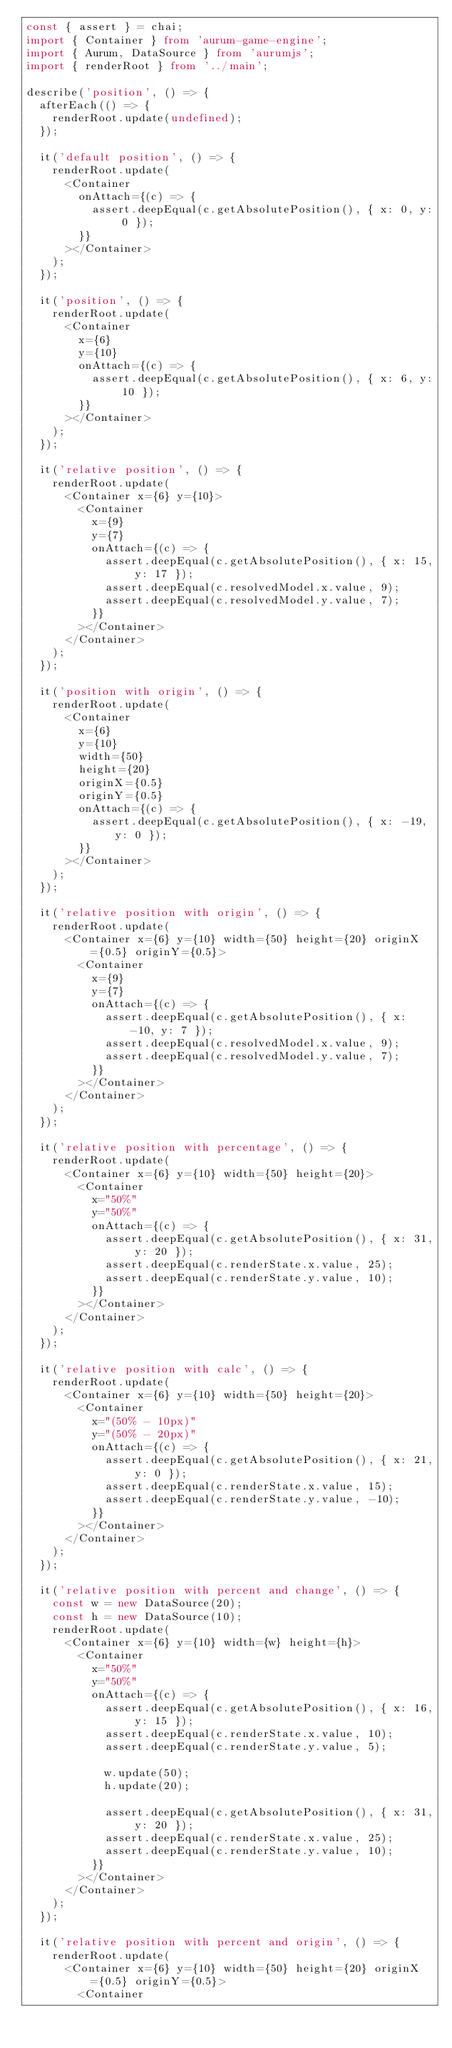Convert code to text. <code><loc_0><loc_0><loc_500><loc_500><_TypeScript_>const { assert } = chai;
import { Container } from 'aurum-game-engine';
import { Aurum, DataSource } from 'aurumjs';
import { renderRoot } from '../main';

describe('position', () => {
	afterEach(() => {
		renderRoot.update(undefined);
	});

	it('default position', () => {
		renderRoot.update(
			<Container
				onAttach={(c) => {
					assert.deepEqual(c.getAbsolutePosition(), { x: 0, y: 0 });
				}}
			></Container>
		);
	});

	it('position', () => {
		renderRoot.update(
			<Container
				x={6}
				y={10}
				onAttach={(c) => {
					assert.deepEqual(c.getAbsolutePosition(), { x: 6, y: 10 });
				}}
			></Container>
		);
	});

	it('relative position', () => {
		renderRoot.update(
			<Container x={6} y={10}>
				<Container
					x={9}
					y={7}
					onAttach={(c) => {
						assert.deepEqual(c.getAbsolutePosition(), { x: 15, y: 17 });
						assert.deepEqual(c.resolvedModel.x.value, 9);
						assert.deepEqual(c.resolvedModel.y.value, 7);
					}}
				></Container>
			</Container>
		);
	});

	it('position with origin', () => {
		renderRoot.update(
			<Container
				x={6}
				y={10}
				width={50}
				height={20}
				originX={0.5}
				originY={0.5}
				onAttach={(c) => {
					assert.deepEqual(c.getAbsolutePosition(), { x: -19, y: 0 });
				}}
			></Container>
		);
	});

	it('relative position with origin', () => {
		renderRoot.update(
			<Container x={6} y={10} width={50} height={20} originX={0.5} originY={0.5}>
				<Container
					x={9}
					y={7}
					onAttach={(c) => {
						assert.deepEqual(c.getAbsolutePosition(), { x: -10, y: 7 });
						assert.deepEqual(c.resolvedModel.x.value, 9);
						assert.deepEqual(c.resolvedModel.y.value, 7);
					}}
				></Container>
			</Container>
		);
	});

	it('relative position with percentage', () => {
		renderRoot.update(
			<Container x={6} y={10} width={50} height={20}>
				<Container
					x="50%"
					y="50%"
					onAttach={(c) => {
						assert.deepEqual(c.getAbsolutePosition(), { x: 31, y: 20 });
						assert.deepEqual(c.renderState.x.value, 25);
						assert.deepEqual(c.renderState.y.value, 10);
					}}
				></Container>
			</Container>
		);
	});

	it('relative position with calc', () => {
		renderRoot.update(
			<Container x={6} y={10} width={50} height={20}>
				<Container
					x="(50% - 10px)"
					y="(50% - 20px)"
					onAttach={(c) => {
						assert.deepEqual(c.getAbsolutePosition(), { x: 21, y: 0 });
						assert.deepEqual(c.renderState.x.value, 15);
						assert.deepEqual(c.renderState.y.value, -10);
					}}
				></Container>
			</Container>
		);
	});

	it('relative position with percent and change', () => {
		const w = new DataSource(20);
		const h = new DataSource(10);
		renderRoot.update(
			<Container x={6} y={10} width={w} height={h}>
				<Container
					x="50%"
					y="50%"
					onAttach={(c) => {
						assert.deepEqual(c.getAbsolutePosition(), { x: 16, y: 15 });
						assert.deepEqual(c.renderState.x.value, 10);
						assert.deepEqual(c.renderState.y.value, 5);

						w.update(50);
						h.update(20);

						assert.deepEqual(c.getAbsolutePosition(), { x: 31, y: 20 });
						assert.deepEqual(c.renderState.x.value, 25);
						assert.deepEqual(c.renderState.y.value, 10);
					}}
				></Container>
			</Container>
		);
	});

	it('relative position with percent and origin', () => {
		renderRoot.update(
			<Container x={6} y={10} width={50} height={20} originX={0.5} originY={0.5}>
				<Container</code> 